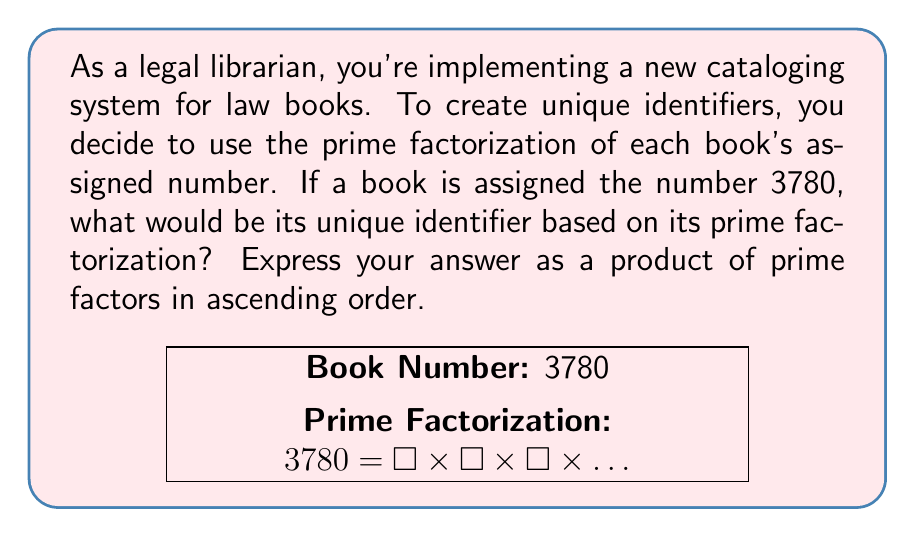Solve this math problem. Let's break this down step-by-step:

1) First, we need to find the prime factors of 3780. We can do this by dividing by the smallest prime number that divides evenly into 3780, and then repeating this process with the quotient until the quotient itself is a prime number.

2) Let's start:
   $3780 = 2 \times 1890$
   $1890 = 2 \times 945$
   $945 = 3 \times 315$
   $315 = 3 \times 105$
   $105 = 3 \times 35$
   $35 = 5 \times 7$

3) Now, let's collect all these prime factors:
   $3780 = 2 \times 2 \times 3 \times 3 \times 3 \times 5 \times 7$

4) Grouping like terms and writing in ascending order:
   $3780 = 2^2 \times 3^3 \times 5 \times 7$

This prime factorization serves as a unique identifier for the book in the cataloging system.
Answer: $2^2 \times 3^3 \times 5 \times 7$ 